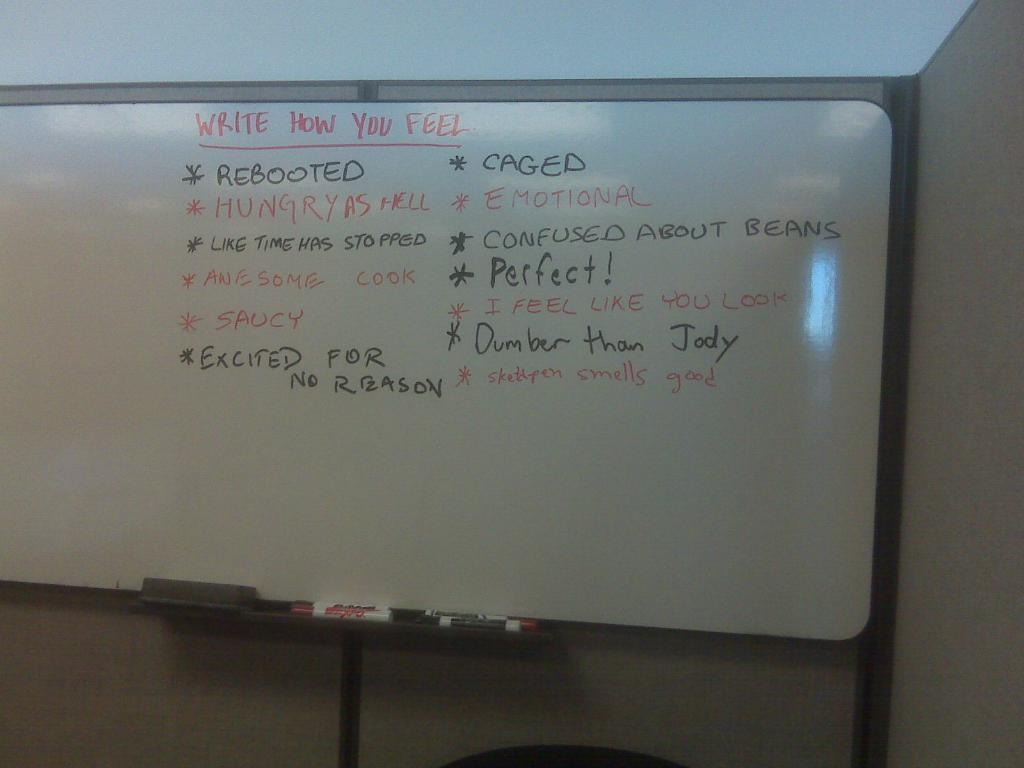<image>
Relay a brief, clear account of the picture shown. A white board has a list on it with the first item being listed as rebooted. 